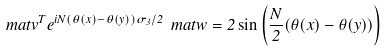<formula> <loc_0><loc_0><loc_500><loc_500>\ m a t { v } ^ { T } e ^ { i N ( \theta ( x ) - \theta ( y ) ) \sigma _ { 3 } / 2 } \ m a t { w } = 2 \sin \left ( \frac { N } { 2 } ( \theta ( x ) - \theta ( y ) ) \right )</formula> 